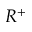Convert formula to latex. <formula><loc_0><loc_0><loc_500><loc_500>R ^ { + }</formula> 